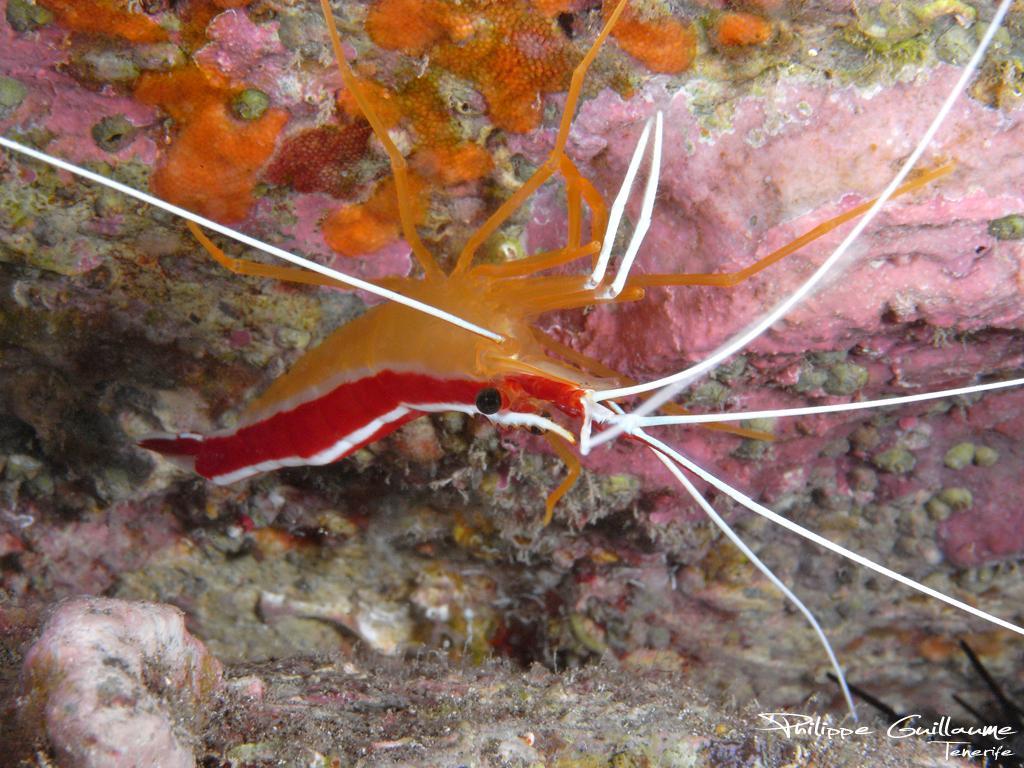Describe this image in one or two sentences. In this image I can see an aquatic animal and the animal is in orange and red color and I can see the colorful background. 